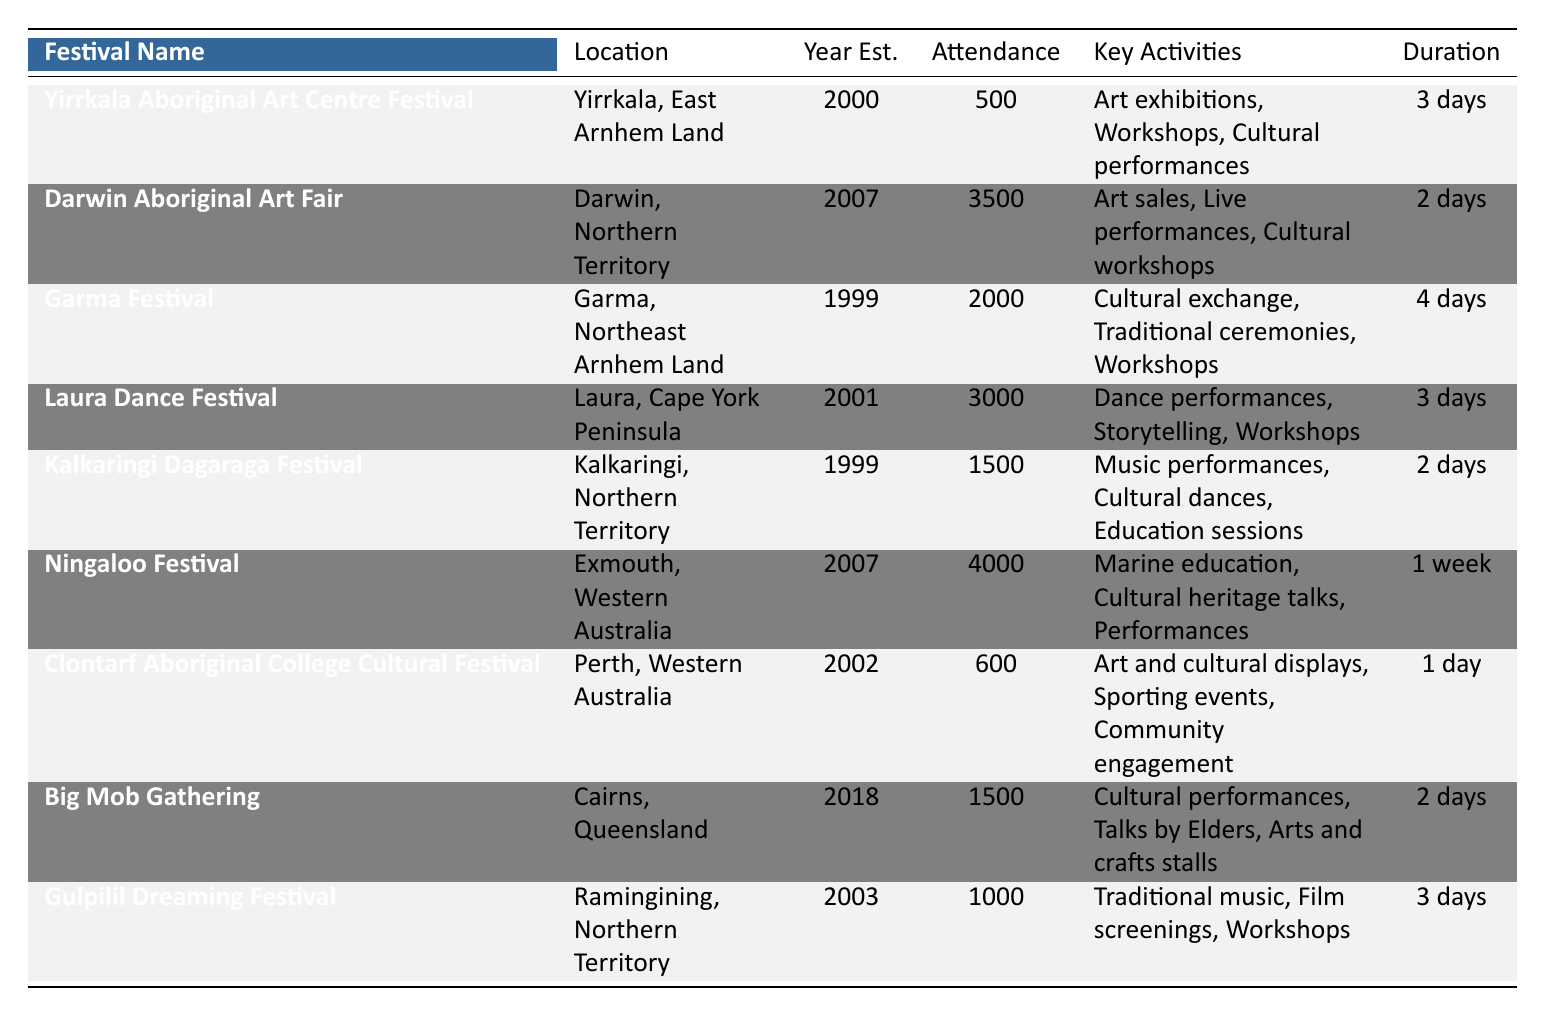What is the typical attendance for the Garma Festival? The table lists the Garma Festival, which shows its typical attendance as 2000.
Answer: 2000 Which festival has the highest typical attendance? By examining the attendance column, the Ningaloo Festival has the highest typical attendance at 4000.
Answer: 4000 How many festivals were established before the year 2000? The festivals established before the year 2000 are Garma Festival and Kalkaringi Dagaraga Festival (both established in 1999) and Yirrkala Aboriginal Art Centre Festival (established in 2000). Therefore, there are three festivals.
Answer: 3 Is the Laura Dance Festival longer in duration than the Darwin Aboriginal Art Fair? The Laura Dance Festival lasts for 3 days while the Darwin Aboriginal Art Fair lasts for 2 days, so yes, the Laura Dance Festival is longer.
Answer: Yes What is the average attendance of the festivals established after 2000? The festivals established after 2000 are the Darwin Aboriginal Art Fair (3500), Laura Dance Festival (3000), Ningaloo Festival (4000), Clontarf Aboriginal College Cultural Festival (600), Big Mob Gathering (1500), and Gulpilil Dreaming Festival (1000). The sum of their attendance is 3500 + 3000 + 4000 + 600 + 1500 + 1000 = 19100. There are 6 festivals, so the average attendance is 19100 / 6 ≈ 3183.33.
Answer: 3183.33 What are the key activities of the Kalkaringi Dagaraga Festival? The key activities listed for the Kalkaringi Dagaraga Festival include music performances, cultural dances, and education sessions.
Answer: Music performances, cultural dances, education sessions 